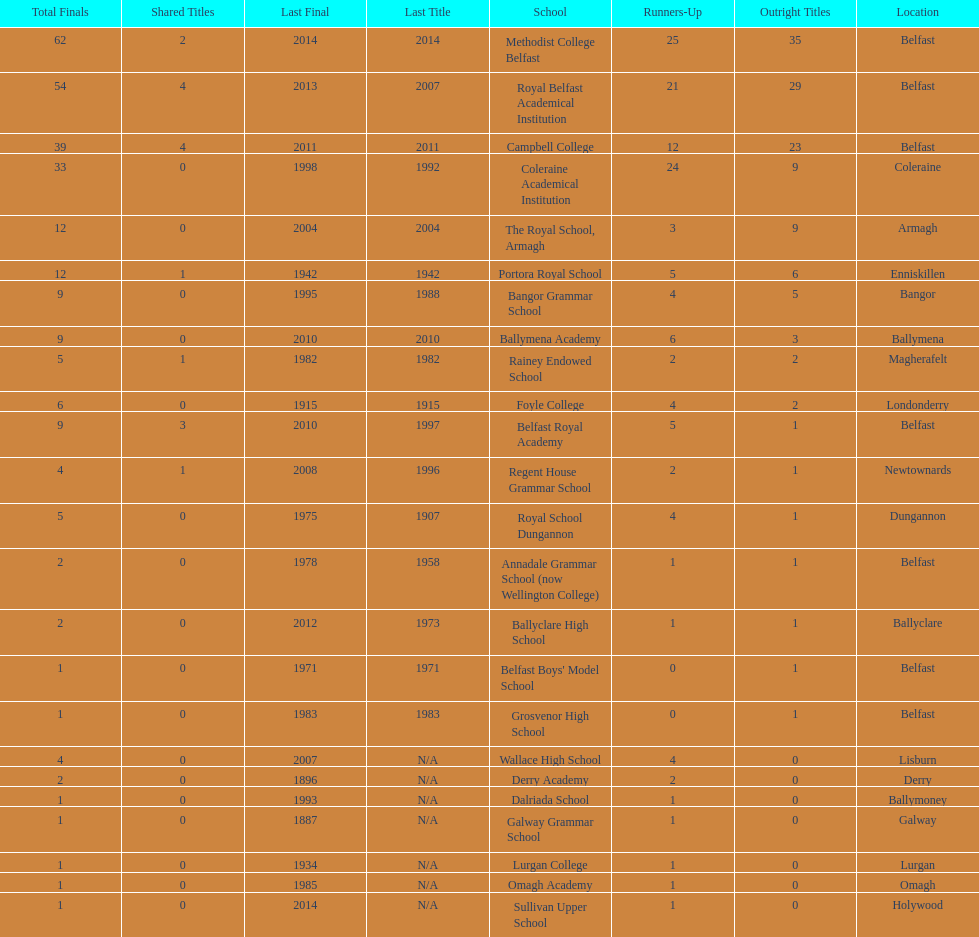In which schools can the greatest amount of common titles be found? Royal Belfast Academical Institution, Campbell College. 